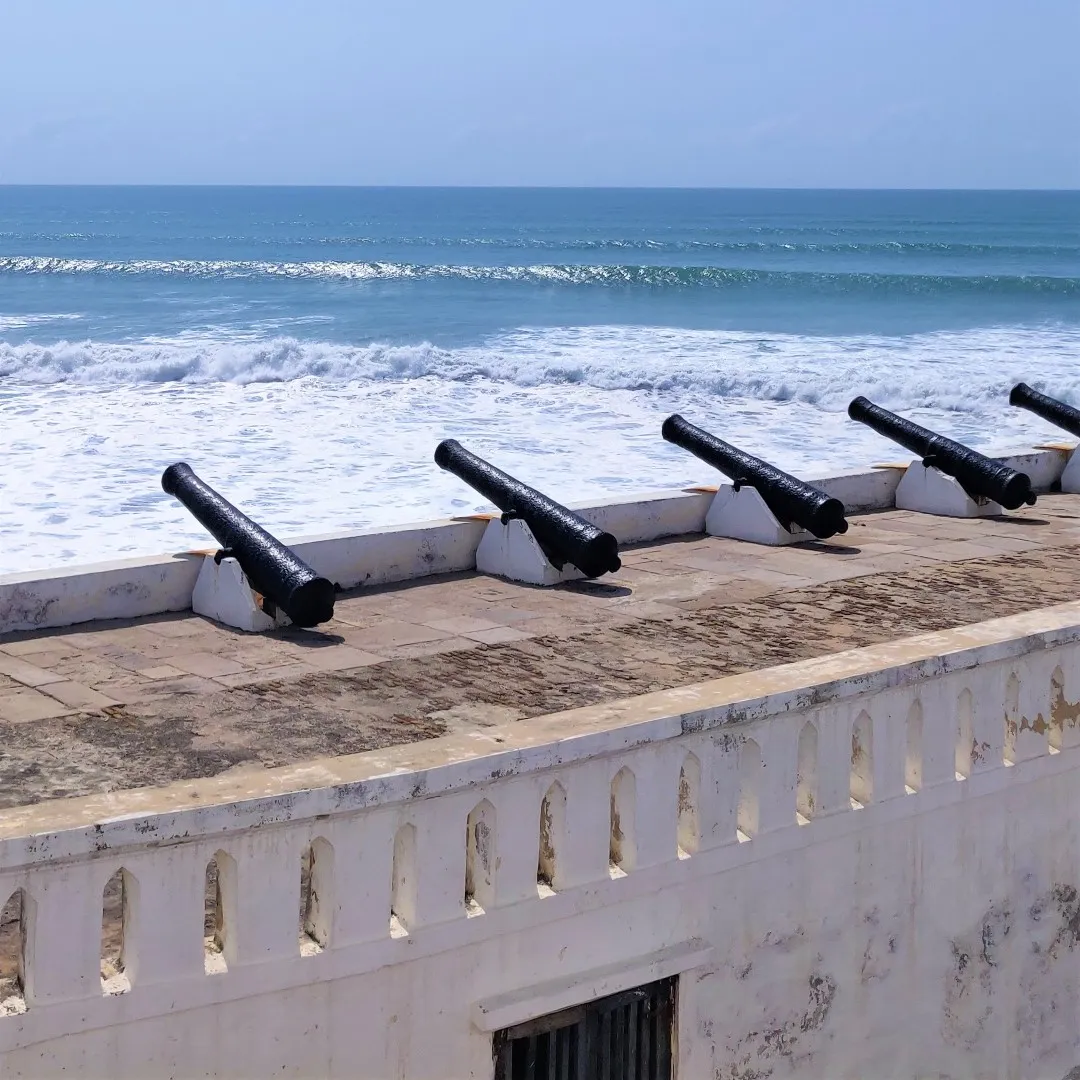What can you say about the historical significance of the objects in this image? The row of black cannons in the image are significant artifacts that harken back to a poignant chapter in history. Positioned on the fortification wall along Ghana's Cape Coast, these cannons were likely part of the defensive structures built by European settlers during the trans-Atlantic slave trade era. These fortifications, including the cannons, were used to protect the coastal points and trading posts from naval threats and to maintain control over the area. The Cape Coast Castle, a prominent historical site nearby, served as one of the most infamous slave-holding sites where countless Africans were held before being shipped off to the Americas. Thus, these cannons stand today as silent sentinels, reminding us of the harsh history and the resilience of the human spirit in the face of adversity. Can you provide a more vivid illustration of the scene and its ambience? Imagine standing on the ancient stone parapet of a coastal fort, the warm tropical breeze ruffling your hair and carrying the scent of the ocean. Before you stretches an endless horizon where the sea blends seamlessly into the sky, both painted in varying shades of blue as the sunlight dances off the water's surface. The solid black cannons, their metal surfaces worn smooth by centuries of salt-laden air, are a stark reminder of the fort's formidable past. Each cannon points resolutely out towards the sea, a somber reminder of the countless lives that passed through this place during the turbulent times of the slave trade. The rhythmic sound of waves crashing against the shore adds a meditative soundtrack to the scene, blending with the distant cries of seabirds. The white walls of the fort, though weathered and cracked, stand strong against the test of time, symbolizing the endurance of memory and history. It's a place where history and nature coexist in a poignant, harmonious tableau. Imagine if one of these cannons could tell its story. What might it say? If one of these ancient cannons could narrate its tale, it might begin with the time it was first forged in a European foundry, its iron surface gleaming under the skilled hands of smiths. It would recount the long, perilous sea voyage it undertook to reach the African coast, the sounds of creaking timbers and crashing waves still fresh in its memory. Upon arrival, it would be hauled up to its lofty position on the fort's walls, facing out over the vast, open sea. The cannon would recall the rigorous drills of soldiers, the sharp commands, and the reverberating booms of its own discharges during practice and conflict alike. It would speak of the ships it watched approach, the traders and soldiers who manned it, and its grim role in the defense of a trade that wrought untold suffering. As decades passed, the cannon witnessed the transformation of the fort from a bustling hub of commerce and conflict to a silent monument of contemplation and remembrance. It would describe the relentless march of time, the salty air that gradually eroded its once smooth surface, and the countless sunsets it saw, a witness to history’s unfolding. Considering its volatile history, draft a short story inspired by the cannon’s perspective during a pivotal moment in history. On a stiflingly hot day in the late 18th century, the fort was abuzz with activity. The air was thick with tension as word had spread fast—a fleet of ships was approaching from the horizon, their intentions unknown. The soldiers manning the fort scurried about, preparing defenses and readying the cannons perched solemnly on the white walls. Among them was a cannon that had seen many such days. Its surface, pitted and seasoned by the sea air, shimmered in the harsh sunlight. As soldiers loaded it with gunpowder and shot, it stood silently, a steadfast sentinel waiting for the command to fire. As the fleet drew closer, sails billowing in the wind, the call to arms echoed across the parapet. The cannon's iron heart thudded with a mix of anticipation and dread, knowing well the destructive power it held within. The order was given, and with a deafening boom, it roared to life, a plume of smoke erupting from its muzzle. The shot whistled across the waves, striking the lead ship with a thunderous crash. The ensuing chaos marked yet another grim chapter in its storied history, a moment frozen in time where it served its duty with unerring precision and foreboding power. 